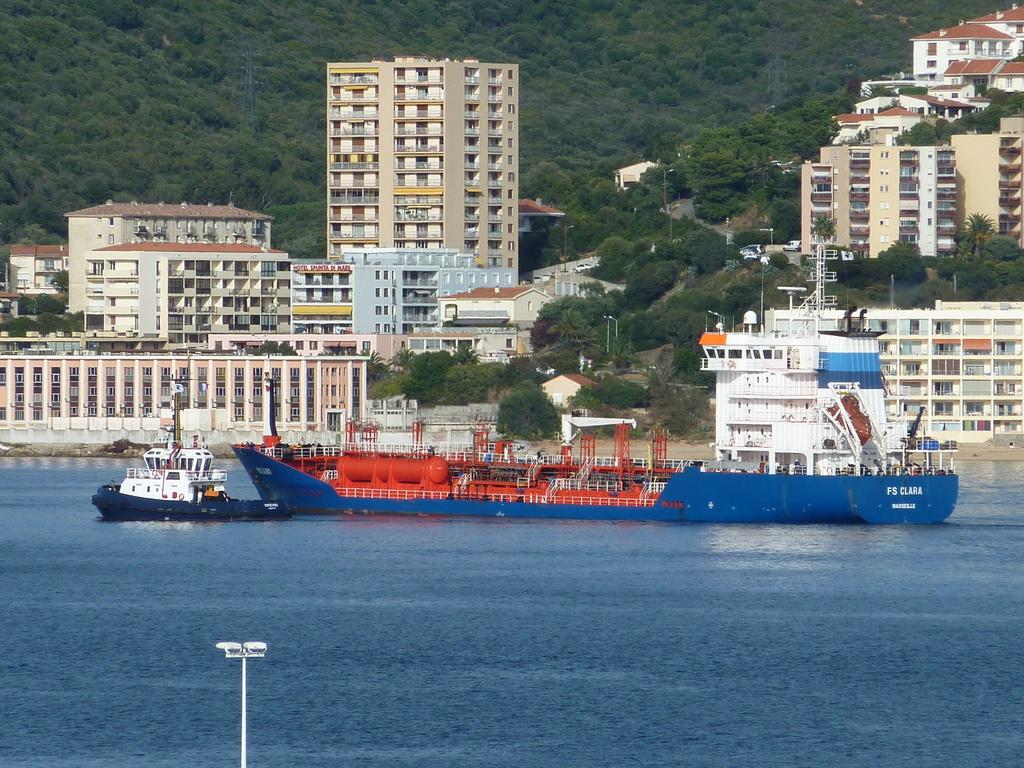What type of watercraft can be seen in the image? There is a ship and a boat in the image. Where are the ship and boat located in the image? Both the ship and boat are on the water in the image. What can be seen in the background of the image? There are buildings and trees in the background of the image. What type of bells can be heard ringing in the image? There are no bells present in the image, and therefore no sound can be heard. 